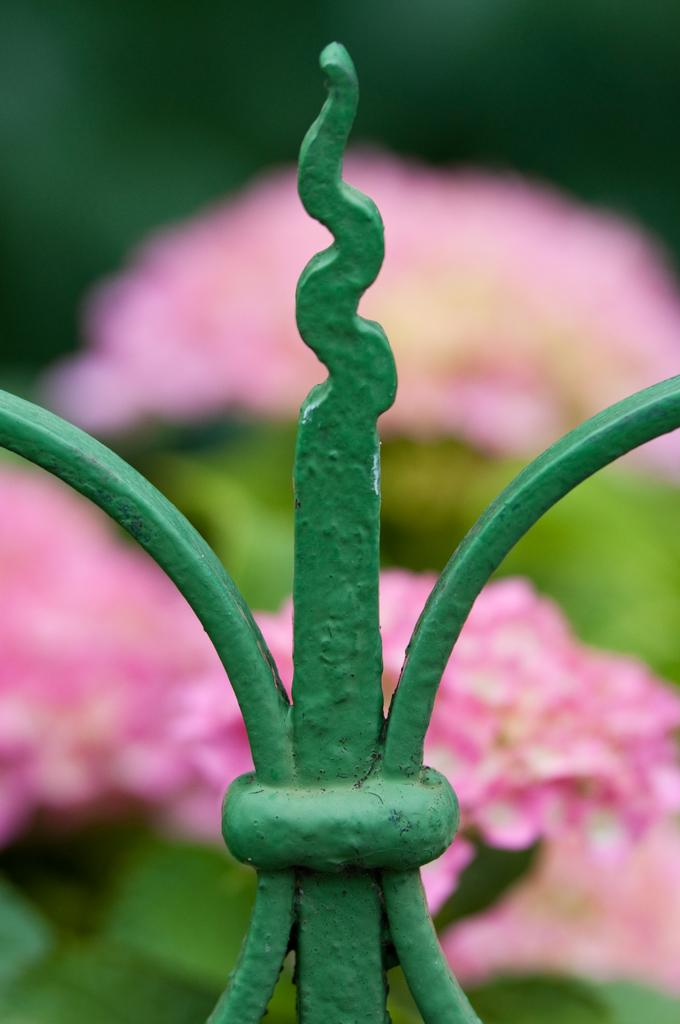What type of living organisms can be seen in the image? There are flowers in the image. What are the flowers being shown to? The flowers are being shown to plants. What is the material of the fence in the image? The fence in the image is made of metal. What is the color of the flowers in the image? The flowers are pink in color. What type of tools does the carpenter use in the image? There is no carpenter present in the image. Can you see any hills in the background of the image? There is no hill visible in the image. What type of insect can be seen interacting with the flowers in the image? There is no insect present in the image. 